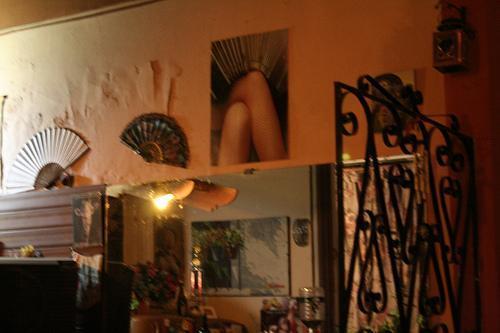How many fans are on the wall?
Give a very brief answer. 2. How many plates hang on the wall?
Give a very brief answer. 0. How many chairs can be seen?
Give a very brief answer. 1. 